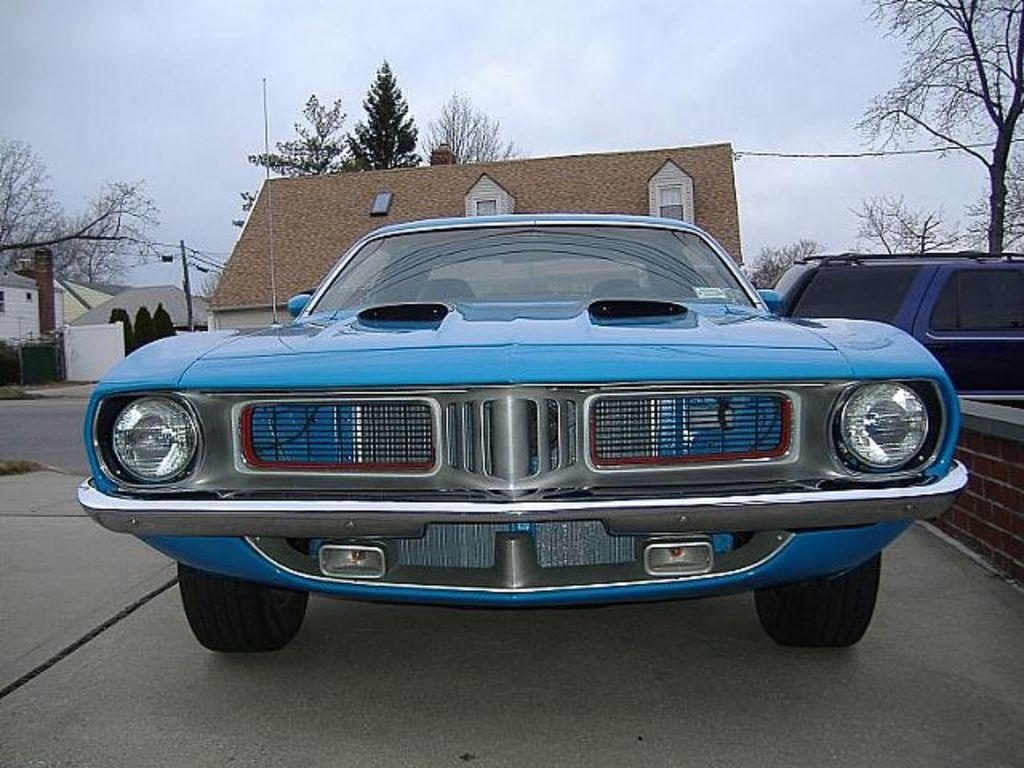What is the main subject of the image? There is a car in the image. What can be seen in the background of the image? There are buildings in the background of the image. What type of vegetation is present in the image? There are trees in the image. What is visible in the sky in the image? The sky is visible in the image. What type of structure is on the right side of the image? There is a brick wall on the right side of the image. What type of beef is being served at the restaurant in the image? There is no restaurant or beef present in the image; it features a car, buildings, trees, sky, and a brick wall. 